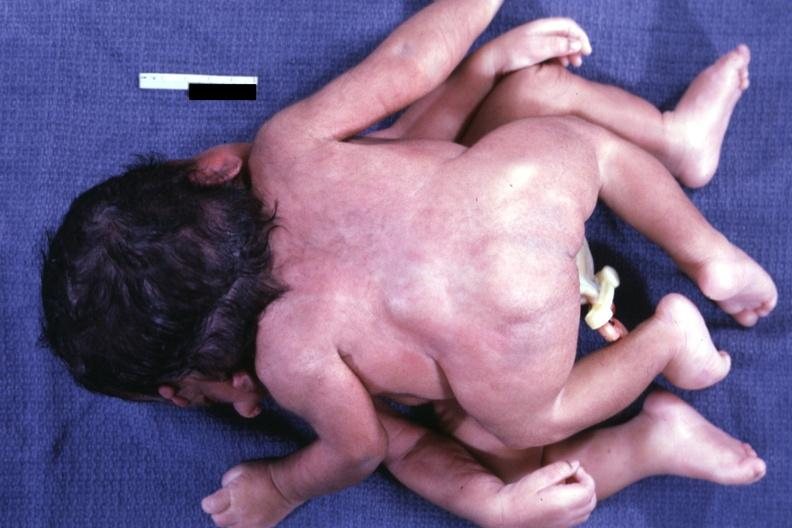what does this image show?
Answer the question using a single word or phrase. Posterior view 